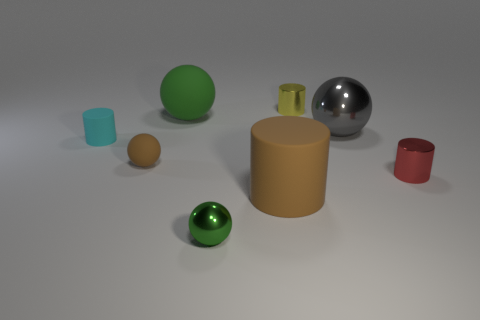Subtract all green shiny spheres. How many spheres are left? 3 Add 1 tiny brown things. How many objects exist? 9 Subtract all gray balls. How many balls are left? 3 Subtract all brown spheres. Subtract all red blocks. How many spheres are left? 3 Subtract all cyan cylinders. How many cyan spheres are left? 0 Subtract all tiny yellow shiny spheres. Subtract all small rubber spheres. How many objects are left? 7 Add 5 red shiny objects. How many red shiny objects are left? 6 Add 4 large cylinders. How many large cylinders exist? 5 Subtract 0 blue balls. How many objects are left? 8 